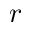Convert formula to latex. <formula><loc_0><loc_0><loc_500><loc_500>r</formula> 